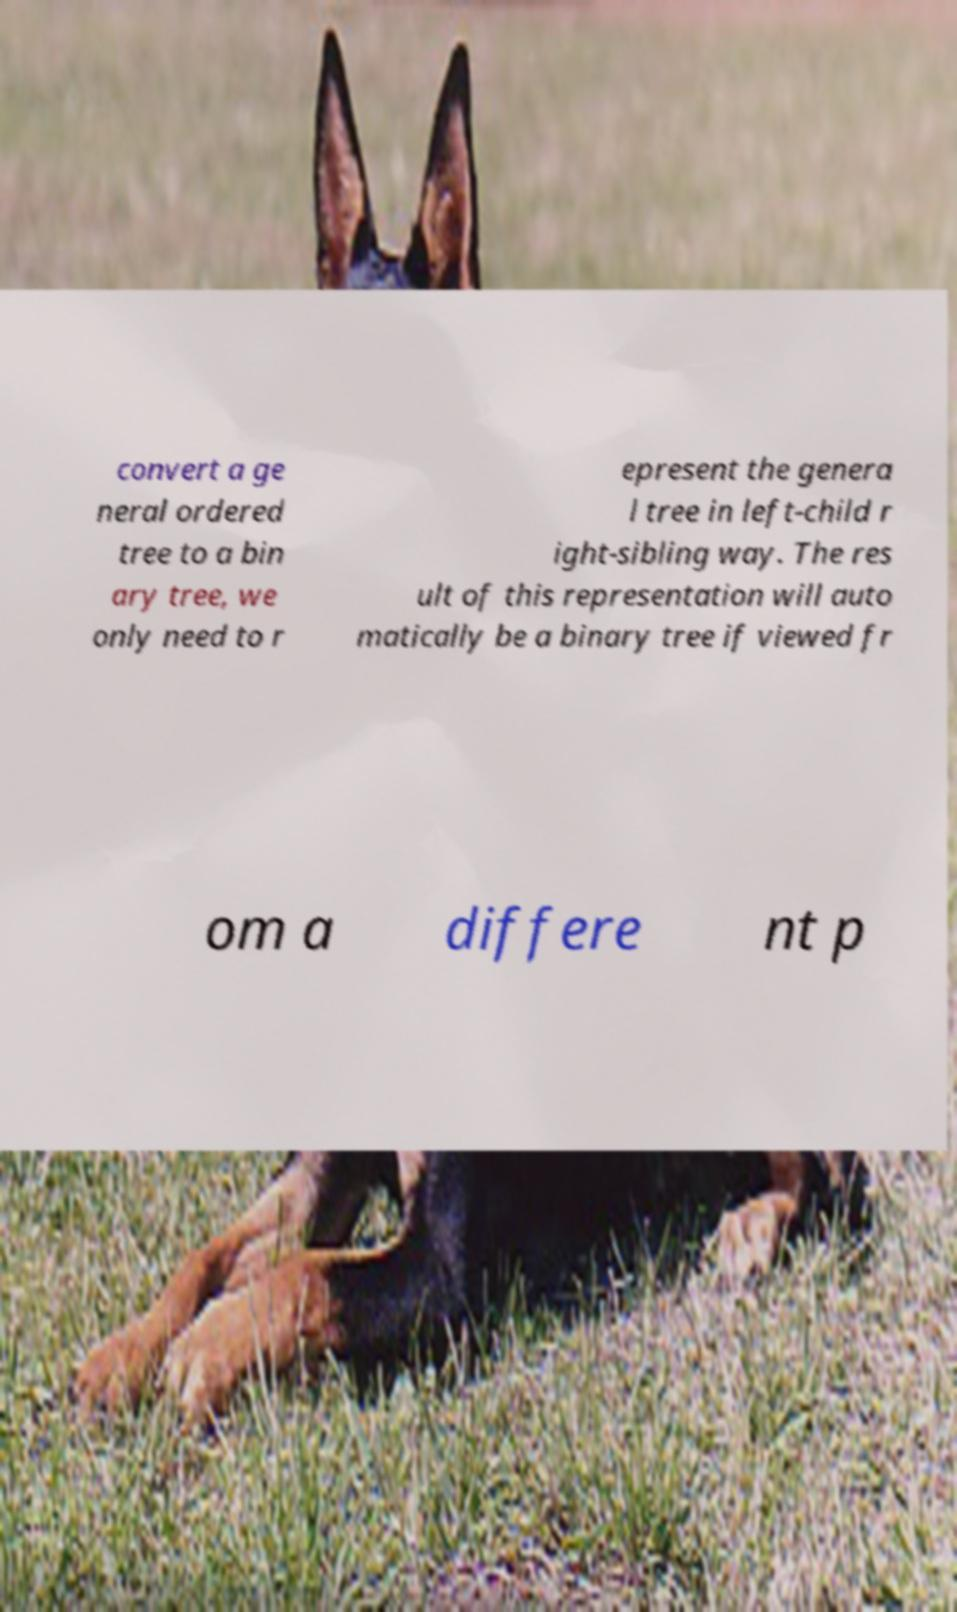Please read and relay the text visible in this image. What does it say? convert a ge neral ordered tree to a bin ary tree, we only need to r epresent the genera l tree in left-child r ight-sibling way. The res ult of this representation will auto matically be a binary tree if viewed fr om a differe nt p 